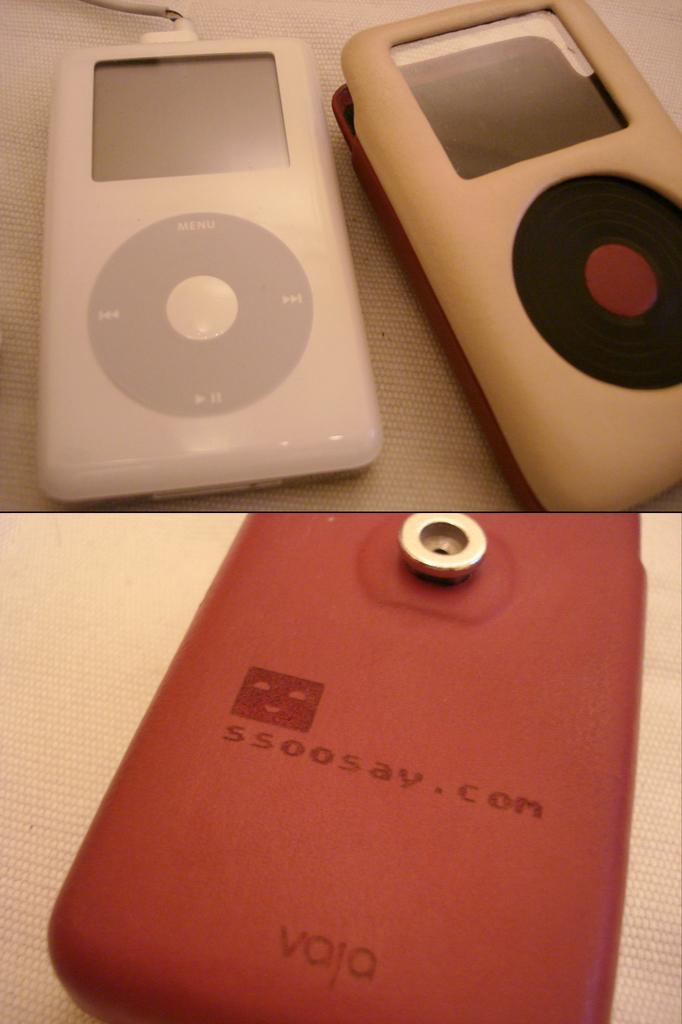What type of electronic device is visible in the image? There are airpods in the image. Where are the airpods located? The airpods are kept on a desk. What type of boat can be seen in the image? There is no boat present in the image; it only features airpods on a desk. 